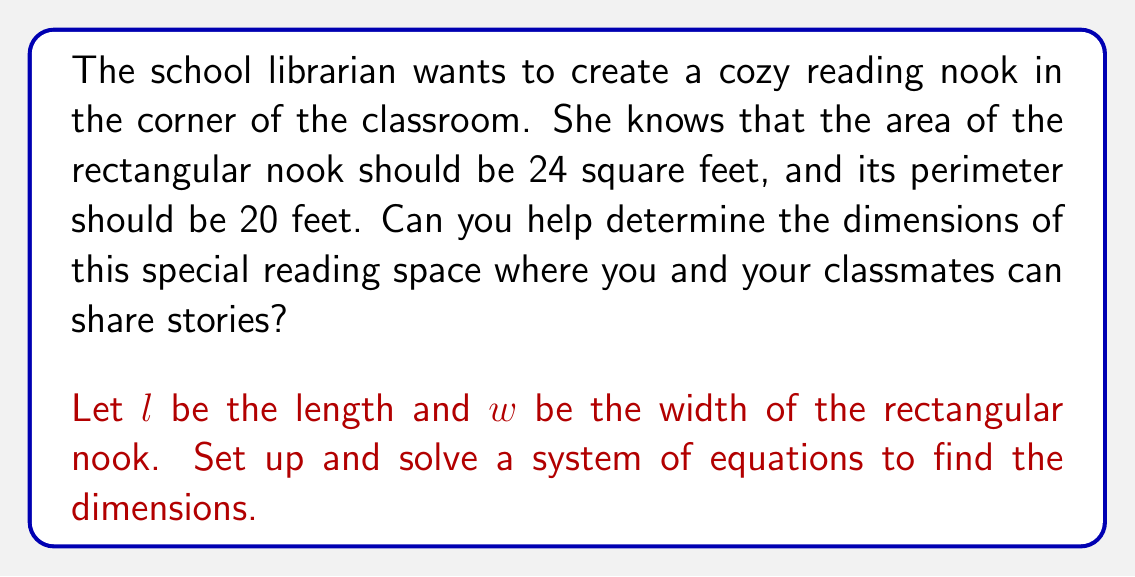Could you help me with this problem? Let's approach this step-by-step:

1) We can set up two equations based on the given information:

   Area equation: $l \cdot w = 24$ (area is 24 square feet)
   Perimeter equation: $2l + 2w = 20$ (perimeter is 20 feet)

2) Let's simplify the perimeter equation:
   $l + w = 10$

3) Now we have a system of two equations:
   $$\begin{cases}
   l \cdot w = 24 \\
   l + w = 10
   \end{cases}$$

4) We can solve this by substitution. From the second equation:
   $l = 10 - w$

5) Substitute this into the first equation:
   $(10 - w) \cdot w = 24$

6) Expand:
   $10w - w^2 = 24$

7) Rearrange to standard form:
   $w^2 - 10w + 24 = 0$

8) This is a quadratic equation. We can solve it using the quadratic formula:
   $w = \frac{-b \pm \sqrt{b^2 - 4ac}}{2a}$

   Where $a = 1$, $b = -10$, and $c = 24$

9) Plugging in these values:
   $w = \frac{10 \pm \sqrt{100 - 96}}{2} = \frac{10 \pm 2}{2}$

10) This gives us two solutions:
    $w = 6$ or $w = 4$

11) If $w = 6$, then $l = 10 - 6 = 4$
    If $w = 4$, then $l = 10 - 4 = 6$

12) Both of these solutions satisfy our original equations. The dimensions of the reading nook could be either 6 feet by 4 feet or 4 feet by 6 feet.
Answer: The dimensions of the reading nook are 6 feet by 4 feet. 